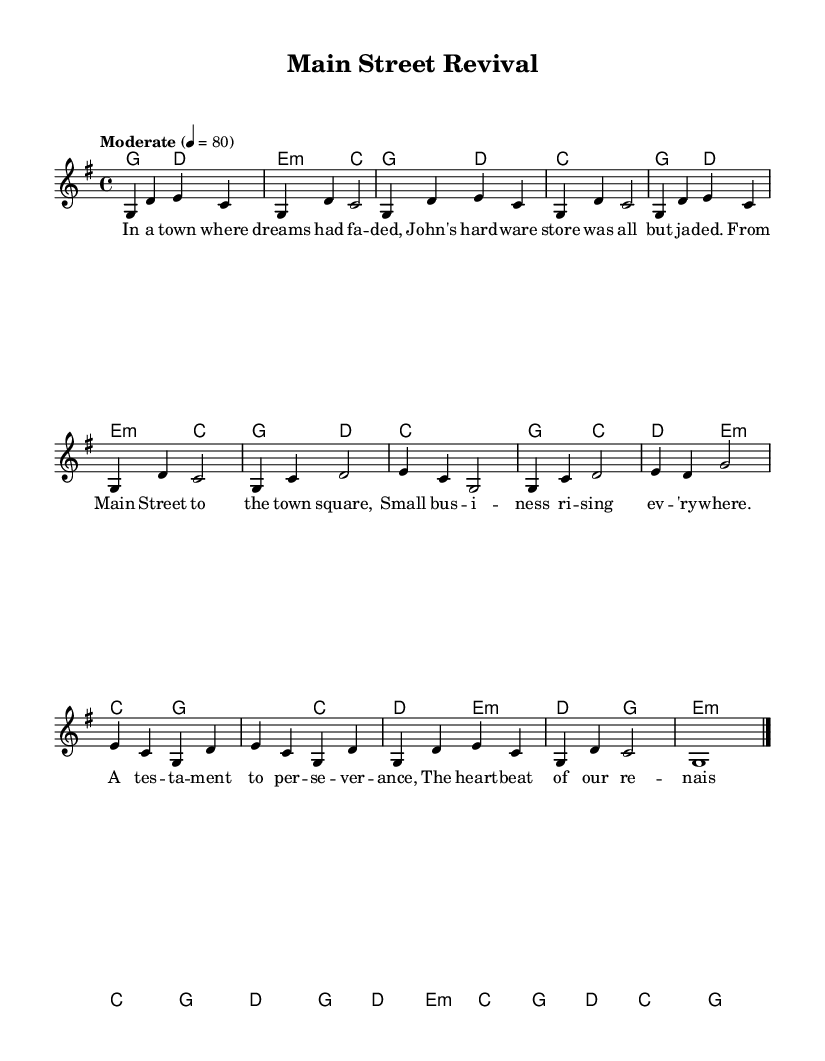What is the key signature of this music? The key signature is G major, which has one sharp (F#). This can be identified through the key signature indication in the music, which is shown at the beginning of the music score.
Answer: G major What is the time signature of this music? The time signature is 4/4, indicated at the beginning of the score. This means there are four beats in each measure, and the quarter note gets one beat.
Answer: 4/4 What is the tempo of this music? The tempo marking indicates "Moderate" at 4 = 80, which suggests a moderate pace with quarter notes being played at 80 beats per minute. The tempo is specified right at the start of the music sheet.
Answer: Moderate 4 = 80 How many measures are in the chorus section? The chorus section consists of four measures, which can be counted from the melody part under the chorus title. Each measure has been clearly notated within the section.
Answer: 4 What is the starting note of the melody? The starting note of the melody is G. This is determined by looking at the first note in the melody line, which is notated in the first measure.
Answer: G Which chord follows the second measure of the intro? The chord that follows the second measure of the intro is E minor. This can be seen in the harmony section, where the chords for the intro are lined up with their respective measures.
Answer: E minor What does the bridge indicate in terms of structure? The bridge section suggests a change or a contrasting idea, typically differentiating it from the verses and chorus. In this score, it serves as a transition that leads back into the outro.
Answer: Transition 